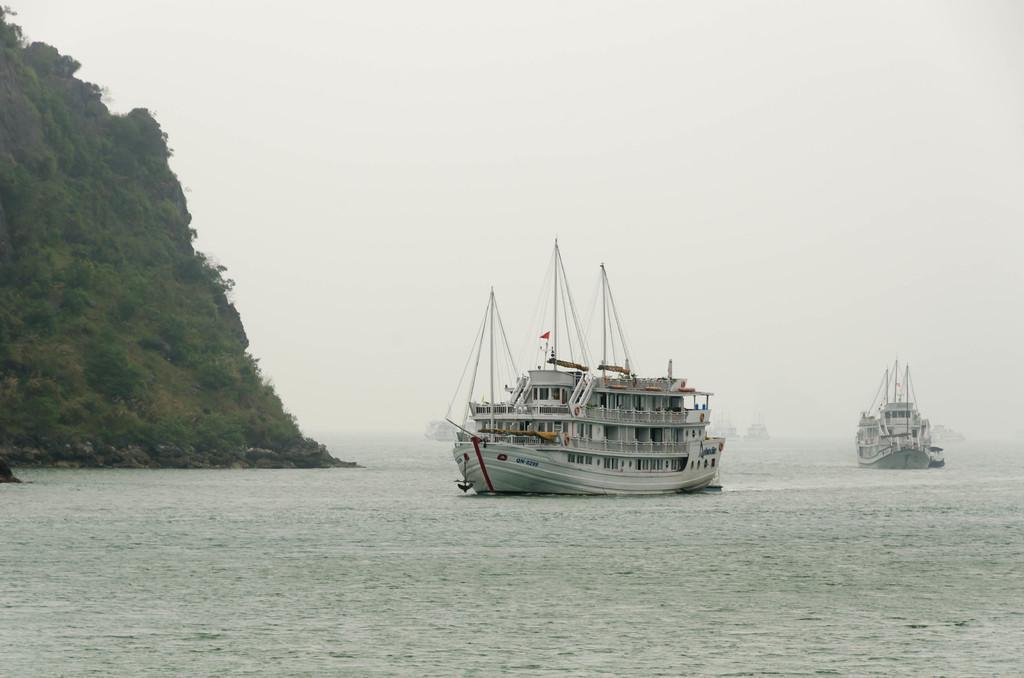Please provide a concise description of this image. In this picture I can observe ships floating on the water. On the left side I can observe hill. In the background there is sky. 